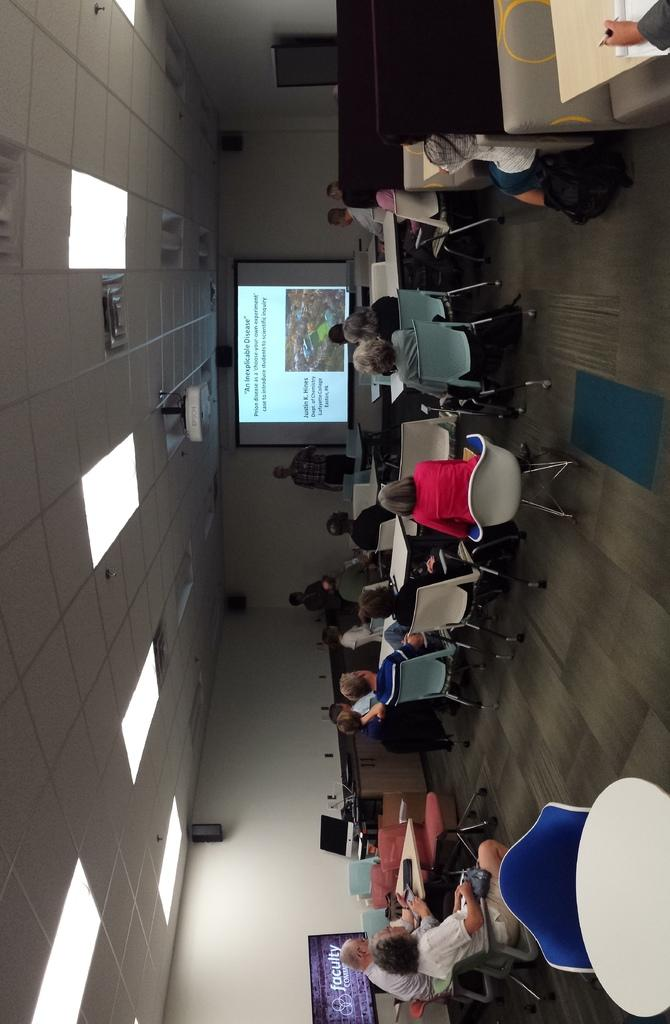Provide a one-sentence caption for the provided image. A classroom full of adults are looking at a projector slide that says An Inexplicable Disease. 